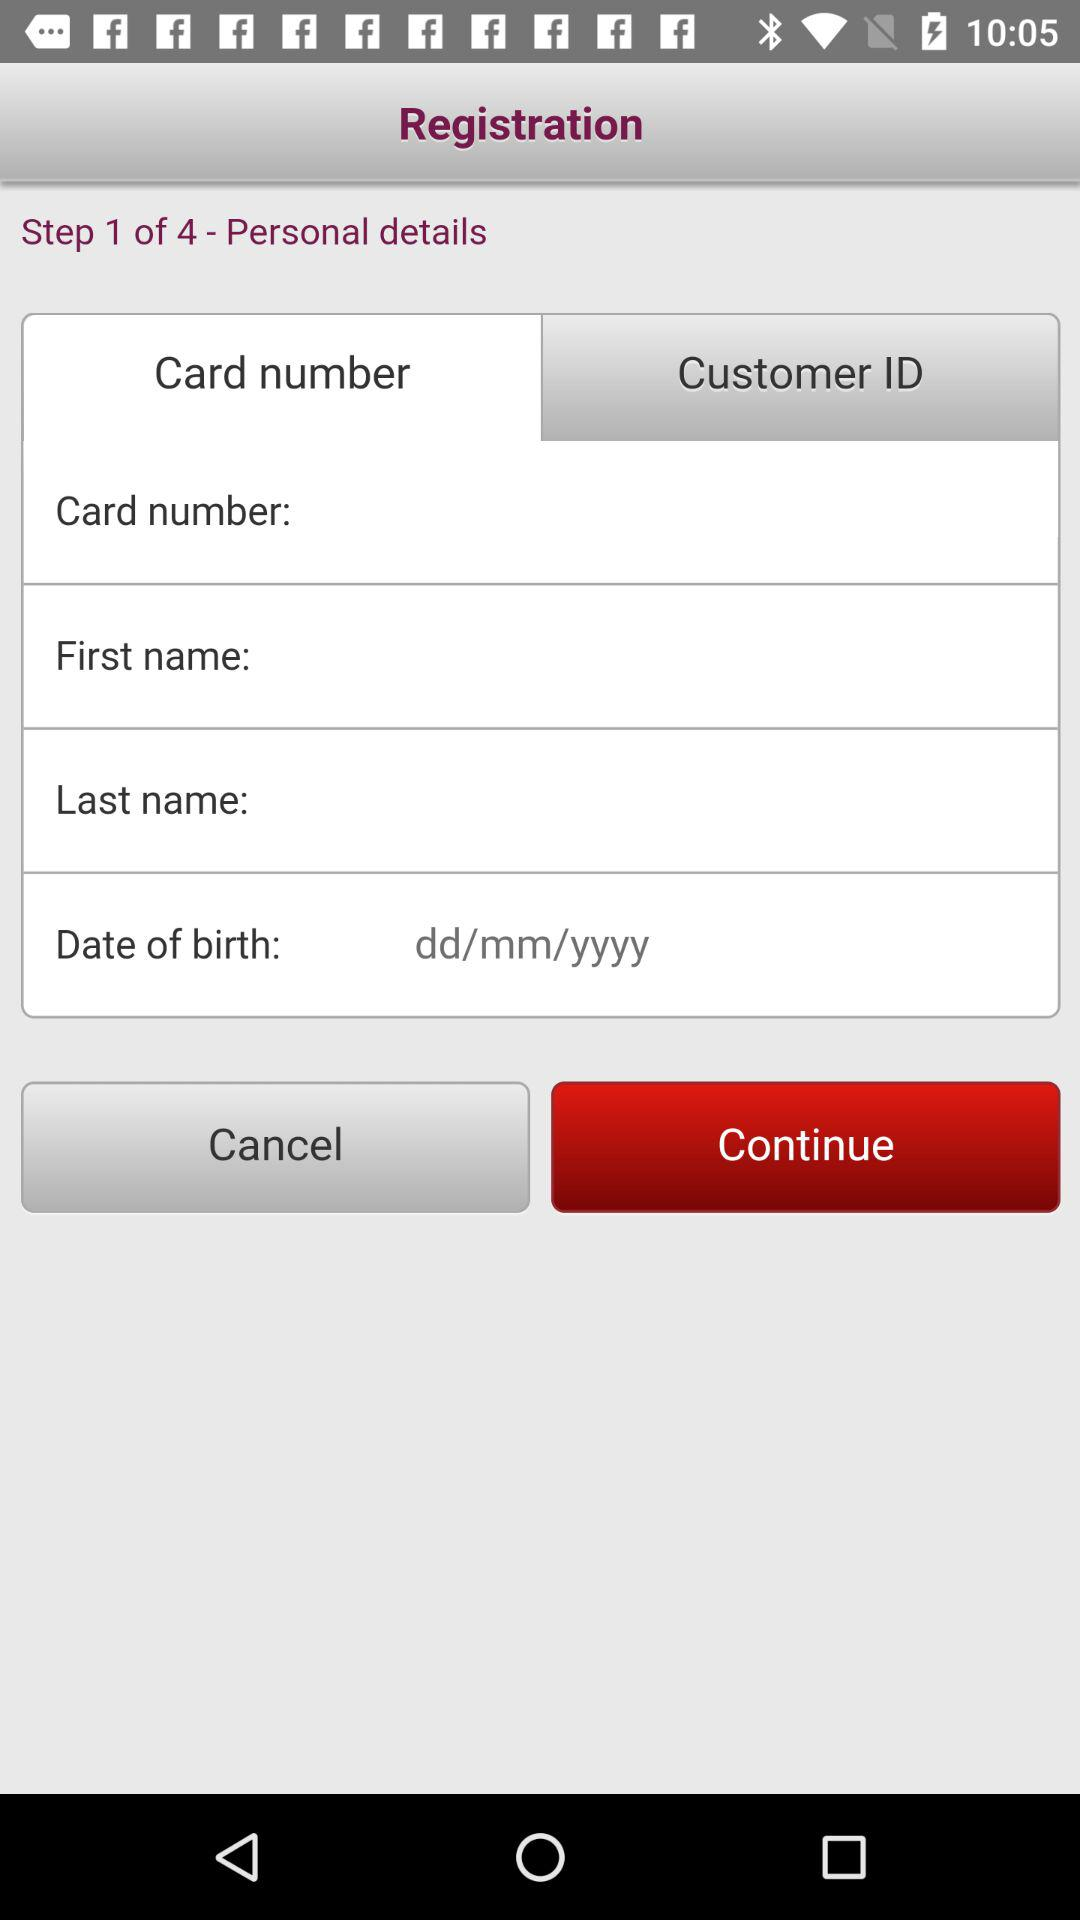At which step am I? You are at the first step. 